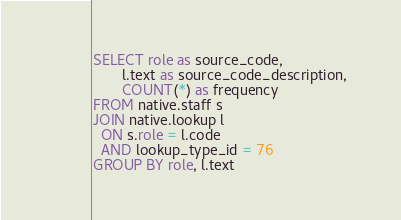<code> <loc_0><loc_0><loc_500><loc_500><_SQL_>
SELECT role as source_code, 
       l.text as source_code_description, 
       COUNT(*) as frequency
FROM native.staff s
JOIN native.lookup l
  ON s.role = l.code
  AND lookup_type_id = 76
GROUP BY role, l.text</code> 